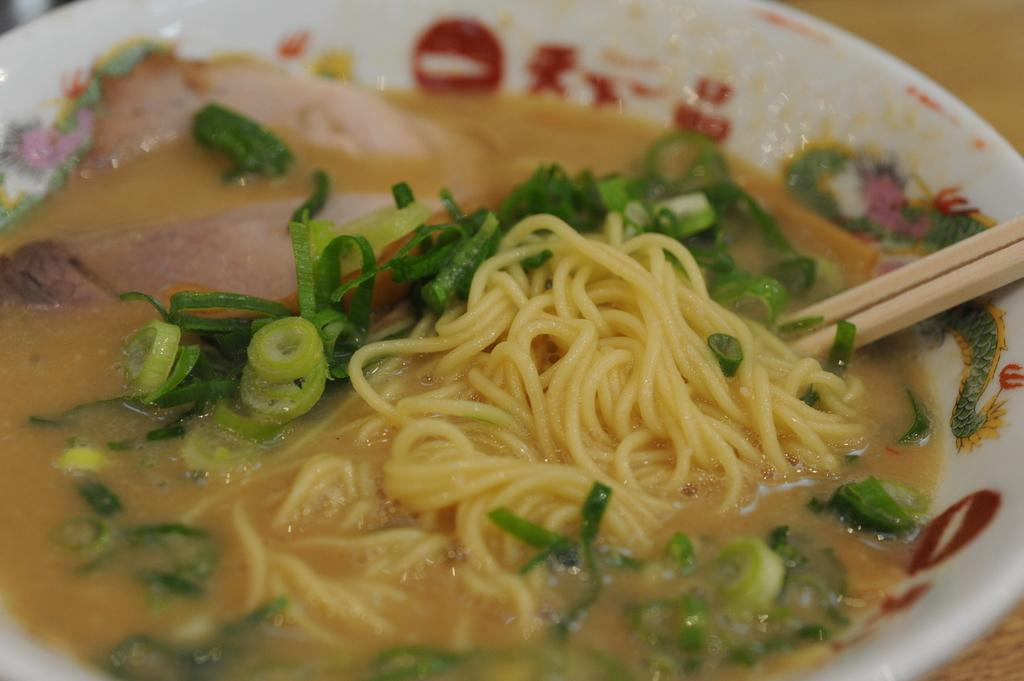What type of food is present in the image? There are noodles and soup in the image. What other ingredients can be seen in the image? There are leafy vegetables in a bowl in the image. What utensil is used to eat the food in the image? Chopsticks are visible in the image. What news story is being discussed at the playground in the image? There is no playground or news story present in the image. 